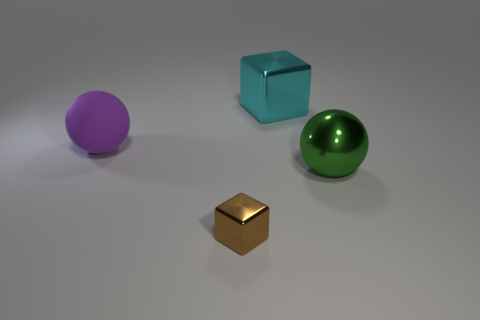The brown object that is the same material as the cyan thing is what shape?
Give a very brief answer. Cube. There is a brown object that is left of the cyan metal thing; what is it made of?
Your response must be concise. Metal. Is there any other thing that is the same color as the small block?
Give a very brief answer. No. What size is the ball that is made of the same material as the tiny cube?
Make the answer very short. Large. What number of large objects are either purple rubber things or brown spheres?
Your response must be concise. 1. What is the size of the rubber object that is left of the shiny cube behind the thing that is in front of the large green sphere?
Your answer should be compact. Large. How many red metallic balls have the same size as the green object?
Make the answer very short. 0. How many things are either yellow rubber cylinders or big metal objects that are right of the cyan object?
Your answer should be compact. 1. The small brown object has what shape?
Make the answer very short. Cube. Is the small metal object the same color as the rubber thing?
Keep it short and to the point. No. 